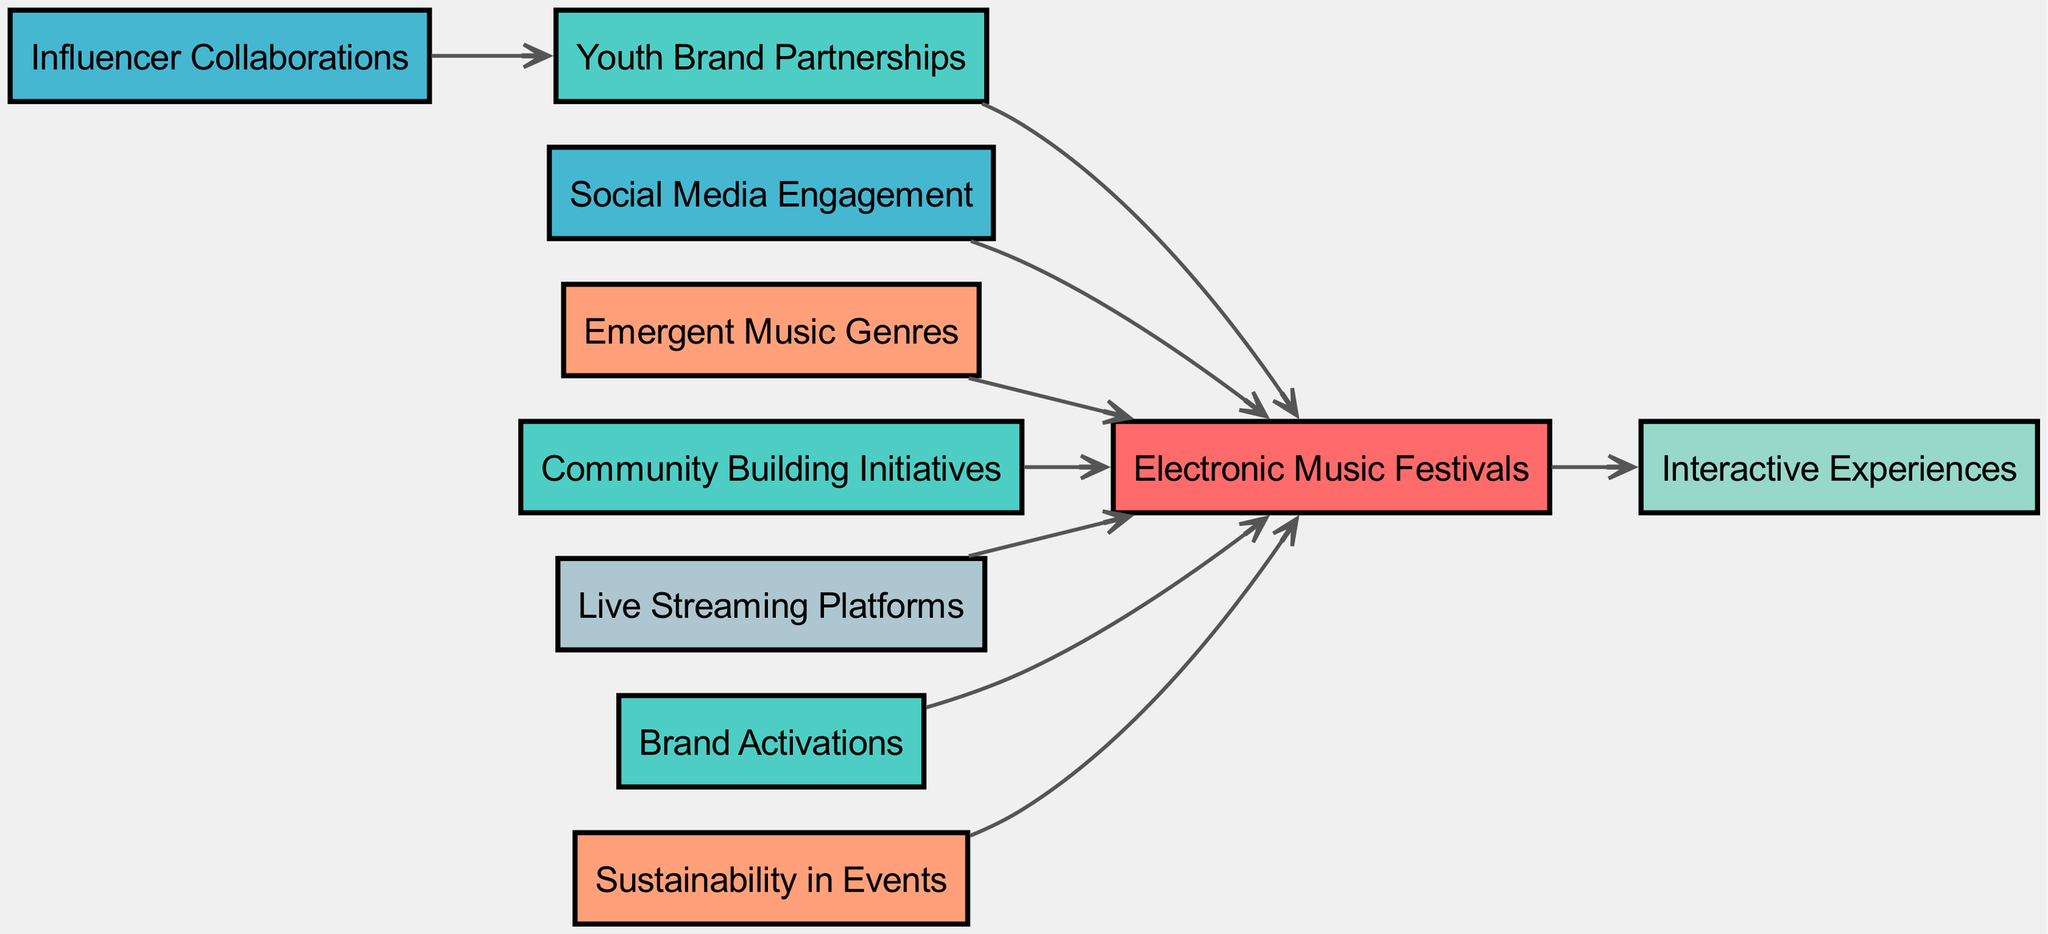What is the total number of elements in the diagram? The diagram contains elements under the 'elements' section that lists 10 individual components. Counting them gives us a total of 10.
Answer: 10 Which node is connected to 'Community Building Initiatives'? From the connections, 'Community Building Initiatives' (node ID 7) is directly connected to 'Electronic Music Festivals' (node ID 1). Therefore, the answer is 'Electronic Music Festivals'.
Answer: Electronic Music Festivals How many types of Strategies are present in the diagram? In the elements section, there are three nodes with the type 'Strategy': 'Youth Brand Partnerships', 'Community Building Initiatives', and 'Brand Activations'. Counting them gives us a total of 3.
Answer: 3 What type is the node 'Live Streaming Platforms'? The node 'Live Streaming Platforms' is categorized under the 'Technology' type as defined in the elements section.
Answer: Technology Which node has the most outbound connections? Analyzing the connections, 'Electronic Music Festivals' (node ID 1) has 7 outbound connections to other nodes. It is the only node with multiple outbound connections, making it the one with the most.
Answer: Electronic Music Festivals Is 'Sustainability in Events' connected to any Tactics? The connections do not list any direct connections from 'Sustainability in Events' to any nodes of the type 'Tactic', confirming that it has no direct relationship with any Tactic node.
Answer: No What is the relationship between 'Influencer Collaborations' and 'Youth Brand Partnerships'? 'Influencer Collaborations' (node ID 4) has a direct connection to 'Youth Brand Partnerships' (node ID 2) as indicated in the connections section. The connection signifies that 'Influencer Collaborations' influences or affects 'Youth Brand Partnerships'.
Answer: Influencer Collaborations influences Youth Brand Partnerships How many engagements are generated from 'Electronic Music Festivals'? By examining the connections, 'Electronic Music Festivals' leads to one engagement node, which is 'Interactive Experiences', indicating that it generates one type of engagement.
Answer: 1 Which type of Trend is associated with 'Electronic Music Festivals'? The node 'Emergent Music Genres' and 'Sustainability in Events' are both categorized as Trends that are connected to 'Electronic Music Festivals', showing its association with these trends.
Answer: Emergent Music Genres, Sustainability in Events 